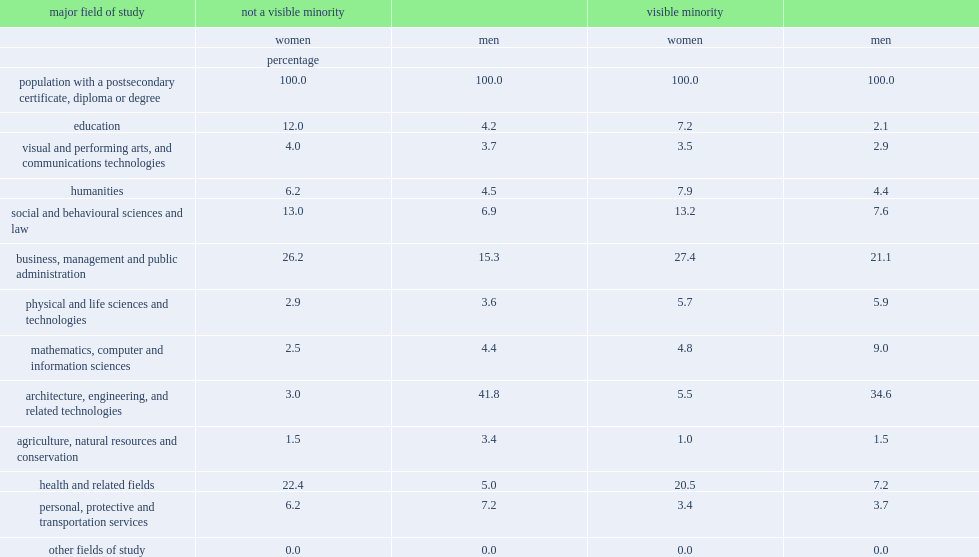The most common field of study among women was business, management and public administration, what was the percentage of visible minority women? 27.4. The most common field of study among women was business, management and public administration, what was the percentage of women who were not a visible minority? 26.2. Health, and related fields, was the major field of study, what was the percentage of visible minority women? 20.5. Health, and related fields, was the major field of study, what was the percentage of women who were not a visible minority? 22.4. Health, and related fields were followed by social and behavioural sciences and law, what was the percentage of women who were not a visible minority? 13.0. 